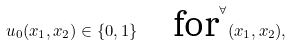<formula> <loc_0><loc_0><loc_500><loc_500>u _ { 0 } ( x _ { 1 } , x _ { 2 } ) \in \{ 0 , 1 \} \quad \text {for} ^ { \forall } ( x _ { 1 } , x _ { 2 } ) ,</formula> 